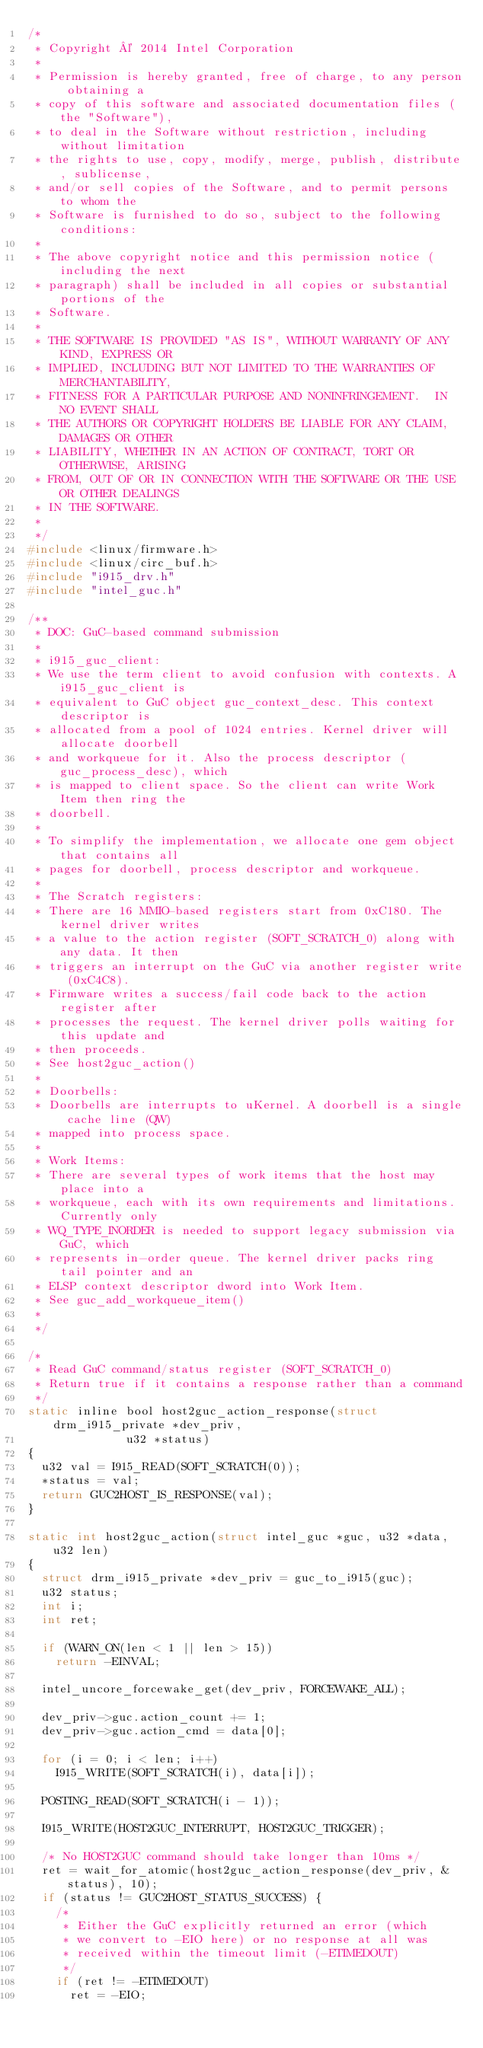<code> <loc_0><loc_0><loc_500><loc_500><_C_>/*
 * Copyright © 2014 Intel Corporation
 *
 * Permission is hereby granted, free of charge, to any person obtaining a
 * copy of this software and associated documentation files (the "Software"),
 * to deal in the Software without restriction, including without limitation
 * the rights to use, copy, modify, merge, publish, distribute, sublicense,
 * and/or sell copies of the Software, and to permit persons to whom the
 * Software is furnished to do so, subject to the following conditions:
 *
 * The above copyright notice and this permission notice (including the next
 * paragraph) shall be included in all copies or substantial portions of the
 * Software.
 *
 * THE SOFTWARE IS PROVIDED "AS IS", WITHOUT WARRANTY OF ANY KIND, EXPRESS OR
 * IMPLIED, INCLUDING BUT NOT LIMITED TO THE WARRANTIES OF MERCHANTABILITY,
 * FITNESS FOR A PARTICULAR PURPOSE AND NONINFRINGEMENT.  IN NO EVENT SHALL
 * THE AUTHORS OR COPYRIGHT HOLDERS BE LIABLE FOR ANY CLAIM, DAMAGES OR OTHER
 * LIABILITY, WHETHER IN AN ACTION OF CONTRACT, TORT OR OTHERWISE, ARISING
 * FROM, OUT OF OR IN CONNECTION WITH THE SOFTWARE OR THE USE OR OTHER DEALINGS
 * IN THE SOFTWARE.
 *
 */
#include <linux/firmware.h>
#include <linux/circ_buf.h>
#include "i915_drv.h"
#include "intel_guc.h"

/**
 * DOC: GuC-based command submission
 *
 * i915_guc_client:
 * We use the term client to avoid confusion with contexts. A i915_guc_client is
 * equivalent to GuC object guc_context_desc. This context descriptor is
 * allocated from a pool of 1024 entries. Kernel driver will allocate doorbell
 * and workqueue for it. Also the process descriptor (guc_process_desc), which
 * is mapped to client space. So the client can write Work Item then ring the
 * doorbell.
 *
 * To simplify the implementation, we allocate one gem object that contains all
 * pages for doorbell, process descriptor and workqueue.
 *
 * The Scratch registers:
 * There are 16 MMIO-based registers start from 0xC180. The kernel driver writes
 * a value to the action register (SOFT_SCRATCH_0) along with any data. It then
 * triggers an interrupt on the GuC via another register write (0xC4C8).
 * Firmware writes a success/fail code back to the action register after
 * processes the request. The kernel driver polls waiting for this update and
 * then proceeds.
 * See host2guc_action()
 *
 * Doorbells:
 * Doorbells are interrupts to uKernel. A doorbell is a single cache line (QW)
 * mapped into process space.
 *
 * Work Items:
 * There are several types of work items that the host may place into a
 * workqueue, each with its own requirements and limitations. Currently only
 * WQ_TYPE_INORDER is needed to support legacy submission via GuC, which
 * represents in-order queue. The kernel driver packs ring tail pointer and an
 * ELSP context descriptor dword into Work Item.
 * See guc_add_workqueue_item()
 *
 */

/*
 * Read GuC command/status register (SOFT_SCRATCH_0)
 * Return true if it contains a response rather than a command
 */
static inline bool host2guc_action_response(struct drm_i915_private *dev_priv,
					    u32 *status)
{
	u32 val = I915_READ(SOFT_SCRATCH(0));
	*status = val;
	return GUC2HOST_IS_RESPONSE(val);
}

static int host2guc_action(struct intel_guc *guc, u32 *data, u32 len)
{
	struct drm_i915_private *dev_priv = guc_to_i915(guc);
	u32 status;
	int i;
	int ret;

	if (WARN_ON(len < 1 || len > 15))
		return -EINVAL;

	intel_uncore_forcewake_get(dev_priv, FORCEWAKE_ALL);

	dev_priv->guc.action_count += 1;
	dev_priv->guc.action_cmd = data[0];

	for (i = 0; i < len; i++)
		I915_WRITE(SOFT_SCRATCH(i), data[i]);

	POSTING_READ(SOFT_SCRATCH(i - 1));

	I915_WRITE(HOST2GUC_INTERRUPT, HOST2GUC_TRIGGER);

	/* No HOST2GUC command should take longer than 10ms */
	ret = wait_for_atomic(host2guc_action_response(dev_priv, &status), 10);
	if (status != GUC2HOST_STATUS_SUCCESS) {
		/*
		 * Either the GuC explicitly returned an error (which
		 * we convert to -EIO here) or no response at all was
		 * received within the timeout limit (-ETIMEDOUT)
		 */
		if (ret != -ETIMEDOUT)
			ret = -EIO;
</code> 